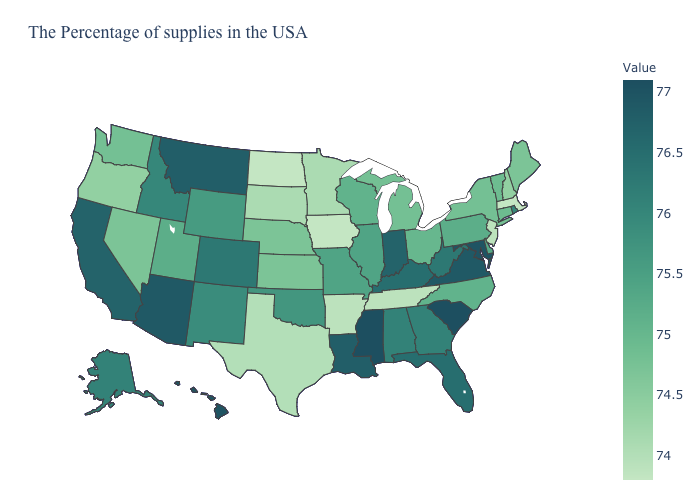Which states have the lowest value in the Northeast?
Short answer required. Massachusetts. Which states have the highest value in the USA?
Be succinct. South Carolina, Mississippi. Does Oregon have the lowest value in the West?
Give a very brief answer. Yes. Among the states that border Nebraska , does Wyoming have the highest value?
Keep it brief. No. 